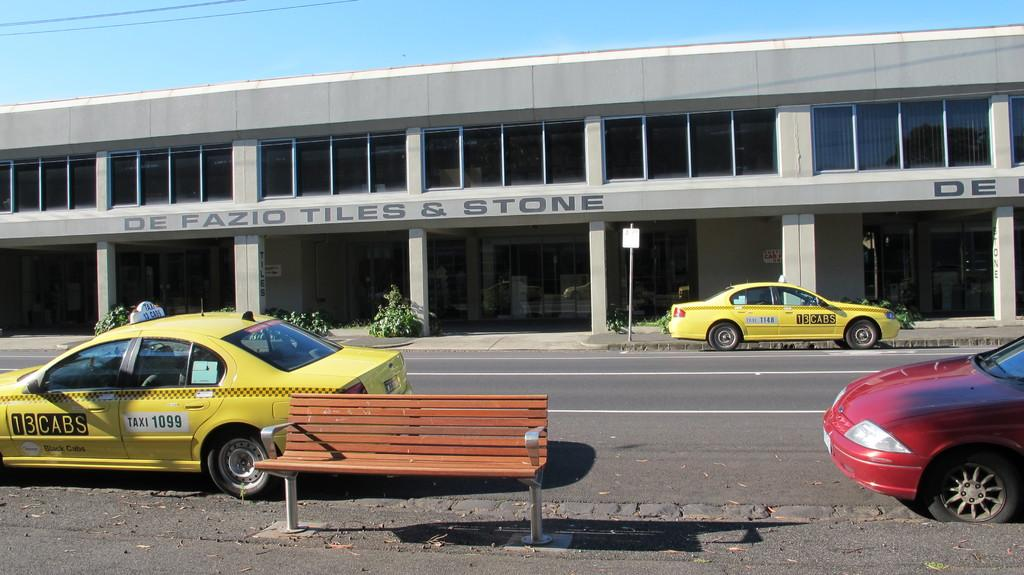Provide a one-sentence caption for the provided image. a building that has a tiles & stone title on it. 